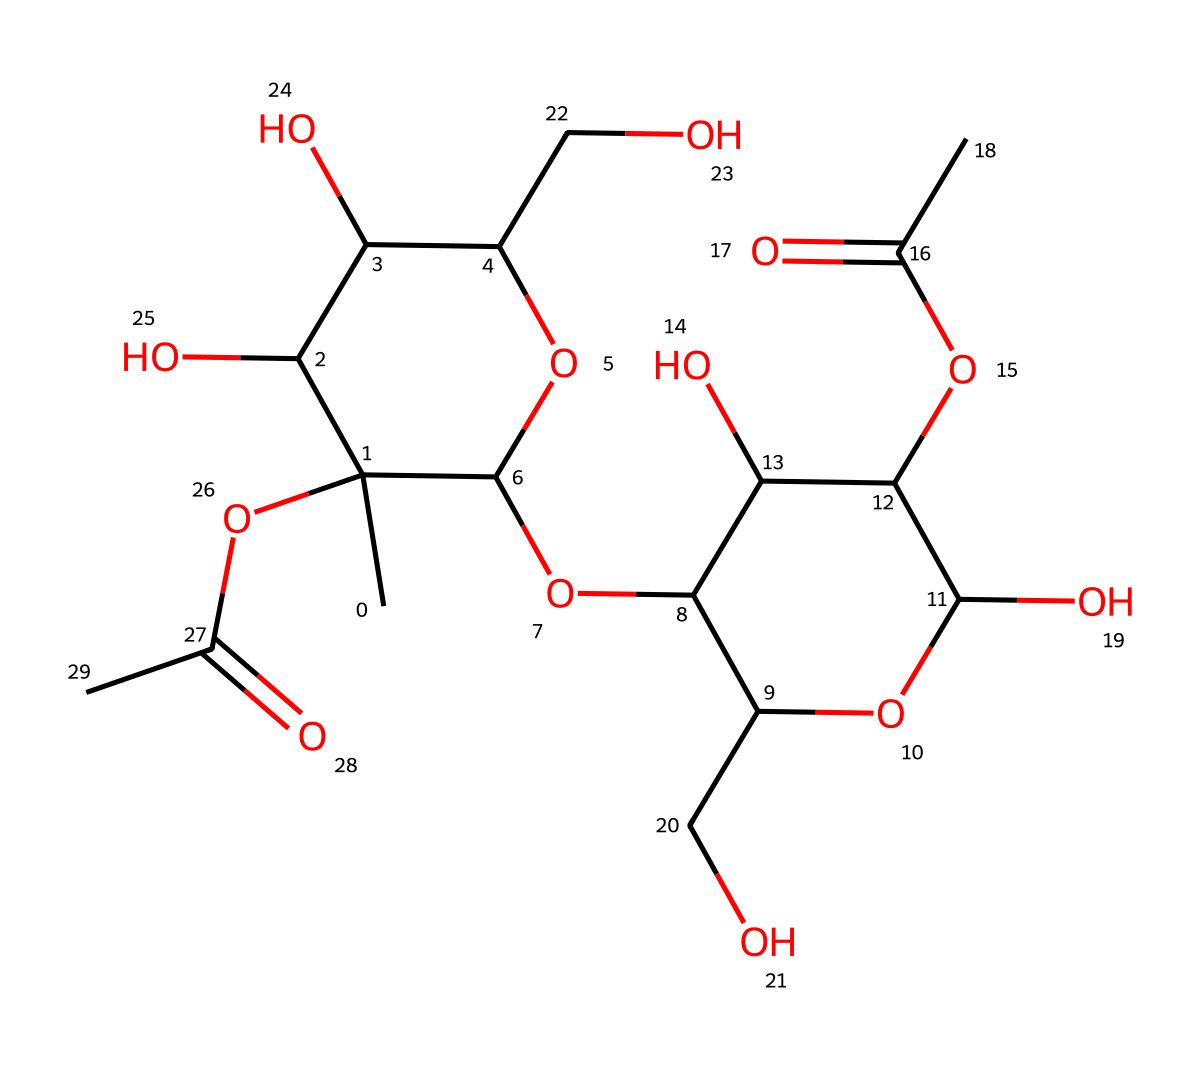What is the main functional group present in this chemical structure? The chemical structure includes carboxyl groups (-COOH) which are identifiable through the presence of carbonyl (C=O) and hydroxyl (OH) functionalities. As these are the defining characteristics of carboxylic acids, we identify carboxyl as the main functional group.
Answer: carboxyl How many hydroxyl (-OH) groups can be found in this molecule? By carefully examining the structure, we can count the number of hydroxyl groups present. Each distinct -OH group in the structural representation can be identified. Upon examining, there are five hydroxyl groups indicated in the structure.
Answer: five What is the molecular formula of this compound based on its structure? To derive the molecular formula, we sum the number of each type of atom present in the structure. From the counts of carbon, hydrogen, and oxygen, we identify that the molecule contains 18 carbons, 32 hydrogens, and 10 oxygens. Thus, the molecular formula is C18H32O10.
Answer: C18H32O10 Is this compound water-soluble? The presence of multiple hydroxyl (-OH) groups in the compound significantly enhances its ability to form hydrogen bonds with water, indicating that it is likely soluble in water.
Answer: yes What role does this compound play in food products? Pectin, derived from apples and other fruits, serves primarily as a gelling agent in food products. This is due to its ability to form gels upon heating and cooling, particularly in the presence of sugar and acid.
Answer: gelling agent 